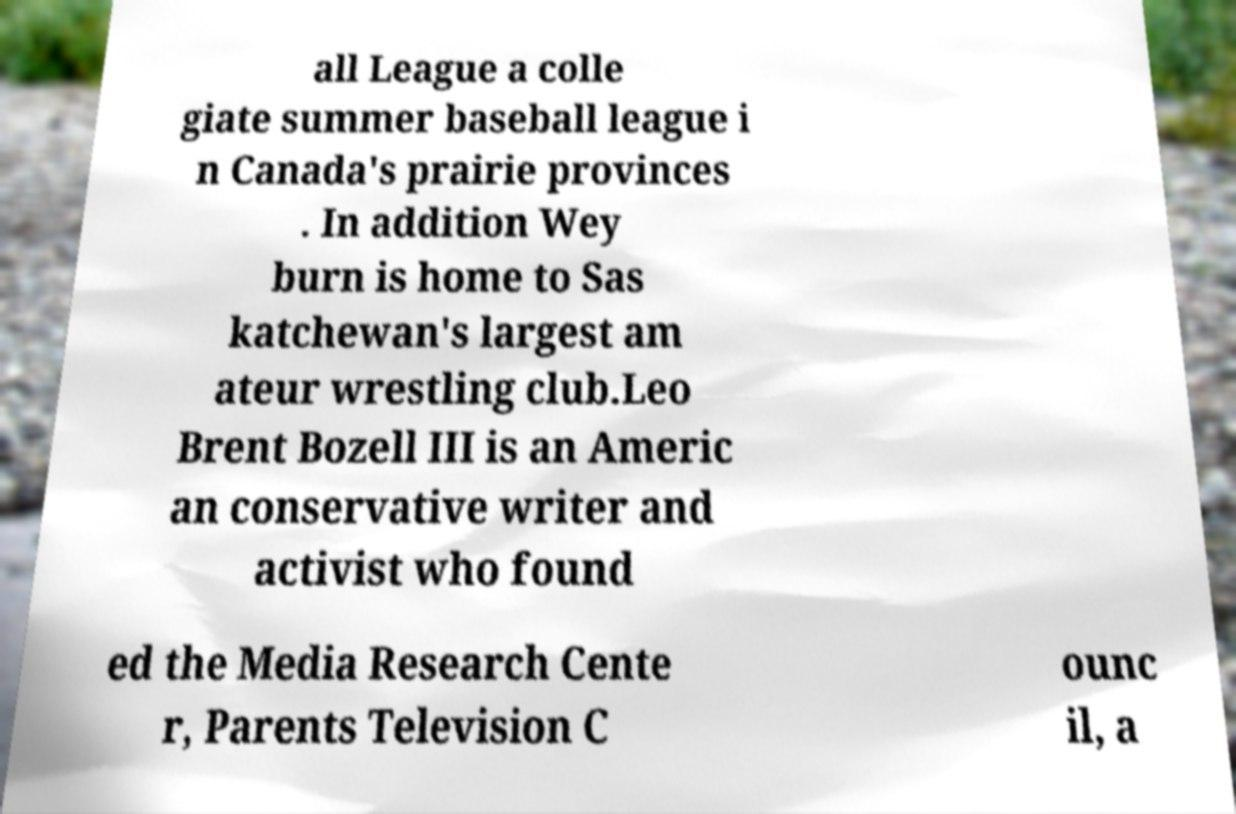Could you assist in decoding the text presented in this image and type it out clearly? all League a colle giate summer baseball league i n Canada's prairie provinces . In addition Wey burn is home to Sas katchewan's largest am ateur wrestling club.Leo Brent Bozell III is an Americ an conservative writer and activist who found ed the Media Research Cente r, Parents Television C ounc il, a 